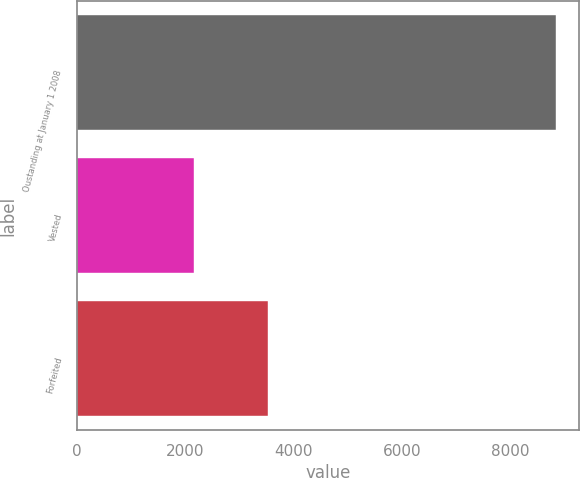<chart> <loc_0><loc_0><loc_500><loc_500><bar_chart><fcel>Oustanding at January 1 2008<fcel>Vested<fcel>Forfeited<nl><fcel>8833<fcel>2156<fcel>3532<nl></chart> 